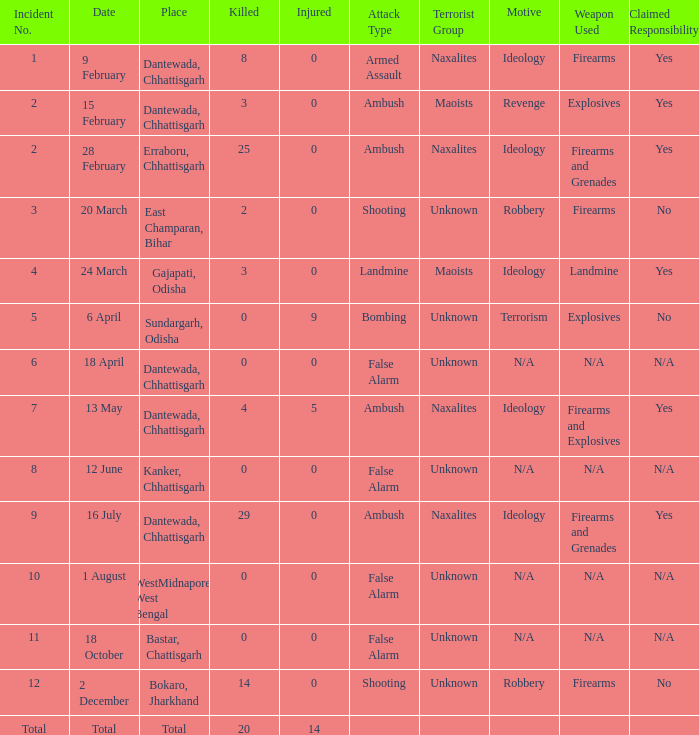How many people were injured in total in East Champaran, Bihar with more than 2 people killed? 0.0. 